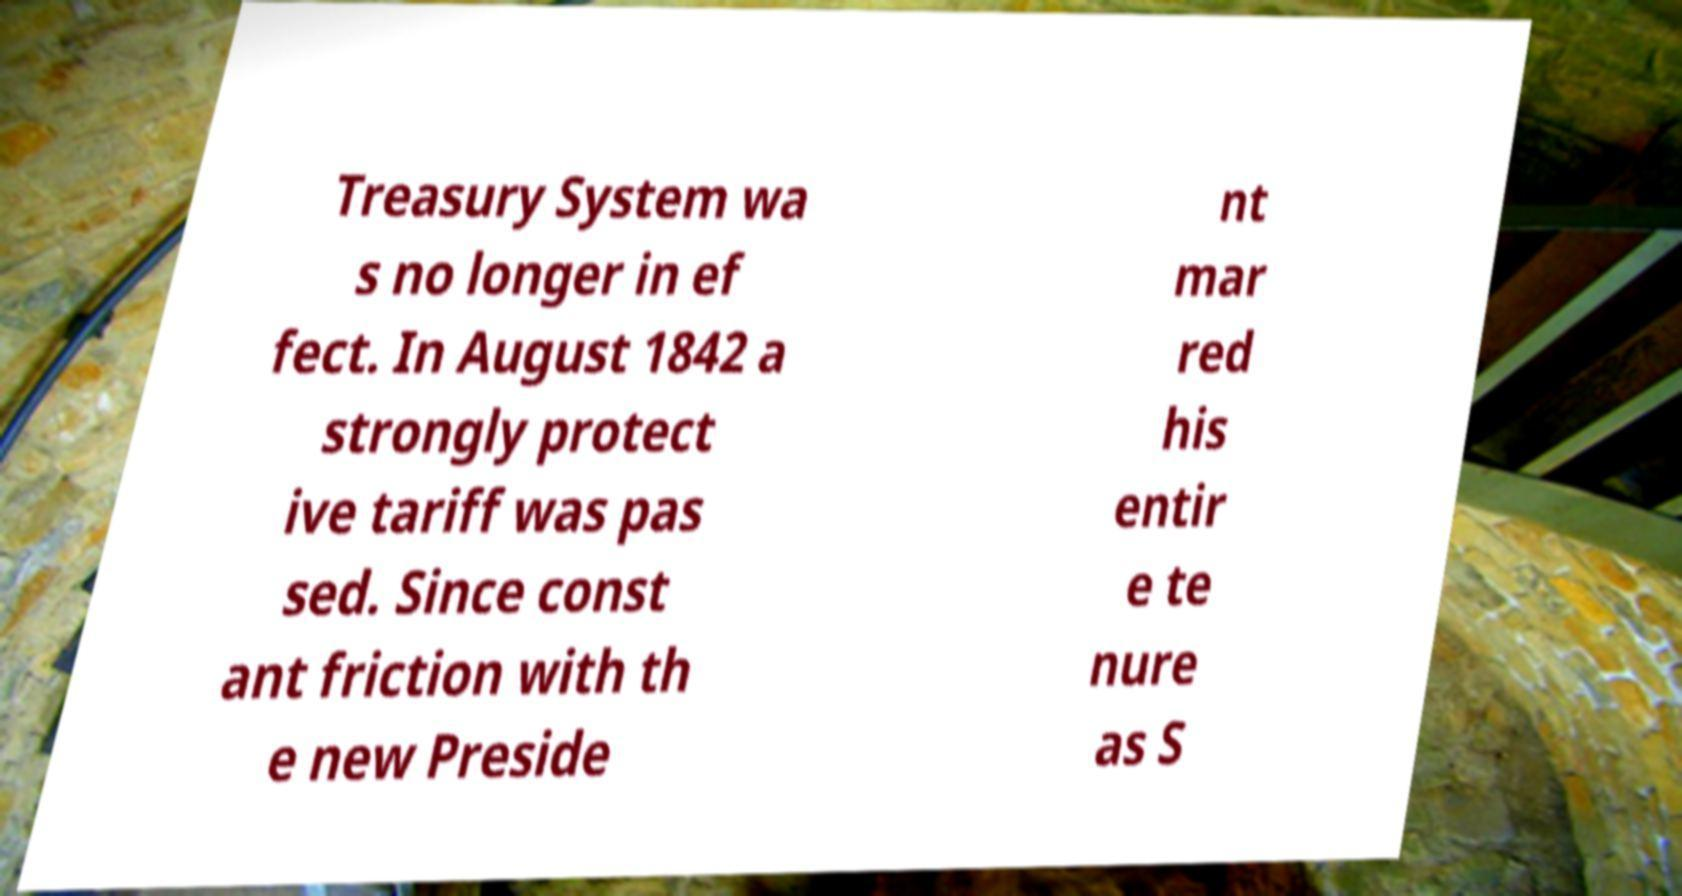Please identify and transcribe the text found in this image. Treasury System wa s no longer in ef fect. In August 1842 a strongly protect ive tariff was pas sed. Since const ant friction with th e new Preside nt mar red his entir e te nure as S 